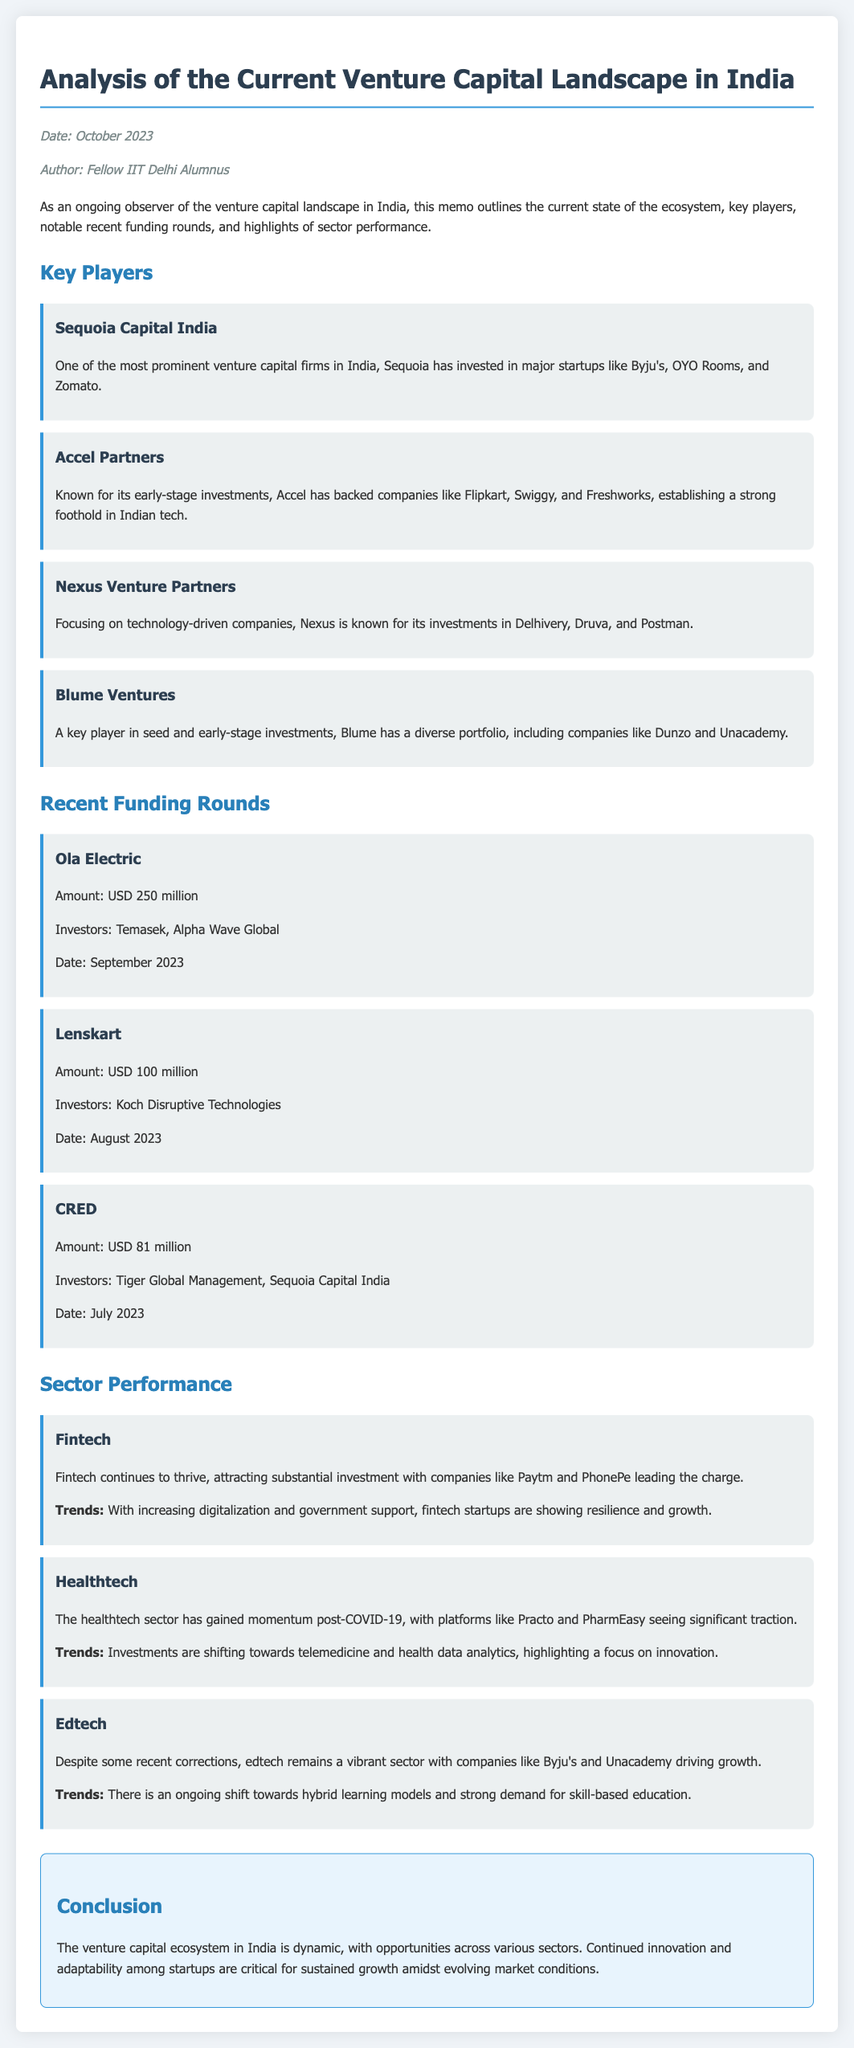What is the date of the memo? The date is mentioned at the top of the document in the meta section.
Answer: October 2023 Which firm invested in Byju's? Byju's is listed as a significant startup that Sequoia Capital India has invested in.
Answer: Sequoia Capital India How much did Ola Electric raise in its recent funding round? The amount raised by Ola Electric is specified under recent funding rounds.
Answer: USD 250 million Who are the investors in CRED's recent funding round? The investors in the funding round for CRED are listed in the document.
Answer: Tiger Global Management, Sequoia Capital India What sector is highlighted as thriving in the document? The fintech sector is identified as thriving in the analysis.
Answer: Fintech Which startup is mentioned as having gained momentum post-COVID-19? The healthtech sector mentions Practo and PharmEasy seeing significant traction.
Answer: Practo What type of investments does Accel Partners focus on? Accel Partners is specified as known for early-stage investments in companies.
Answer: Early-stage investments What financial trend is highlighted for the healthtech sector? The document outlines trends within the healthtech sector focusing on telemedicine and health data analytics.
Answer: Telemedicine and health data analytics What key players are mentioned in the memo? The memo specifies several venture capital firms as key players in the Indian ecosystem.
Answer: Sequoia Capital India, Accel Partners, Nexus Venture Partners, Blume Ventures 